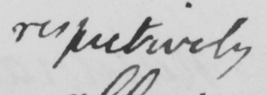What is written in this line of handwriting? respectively 